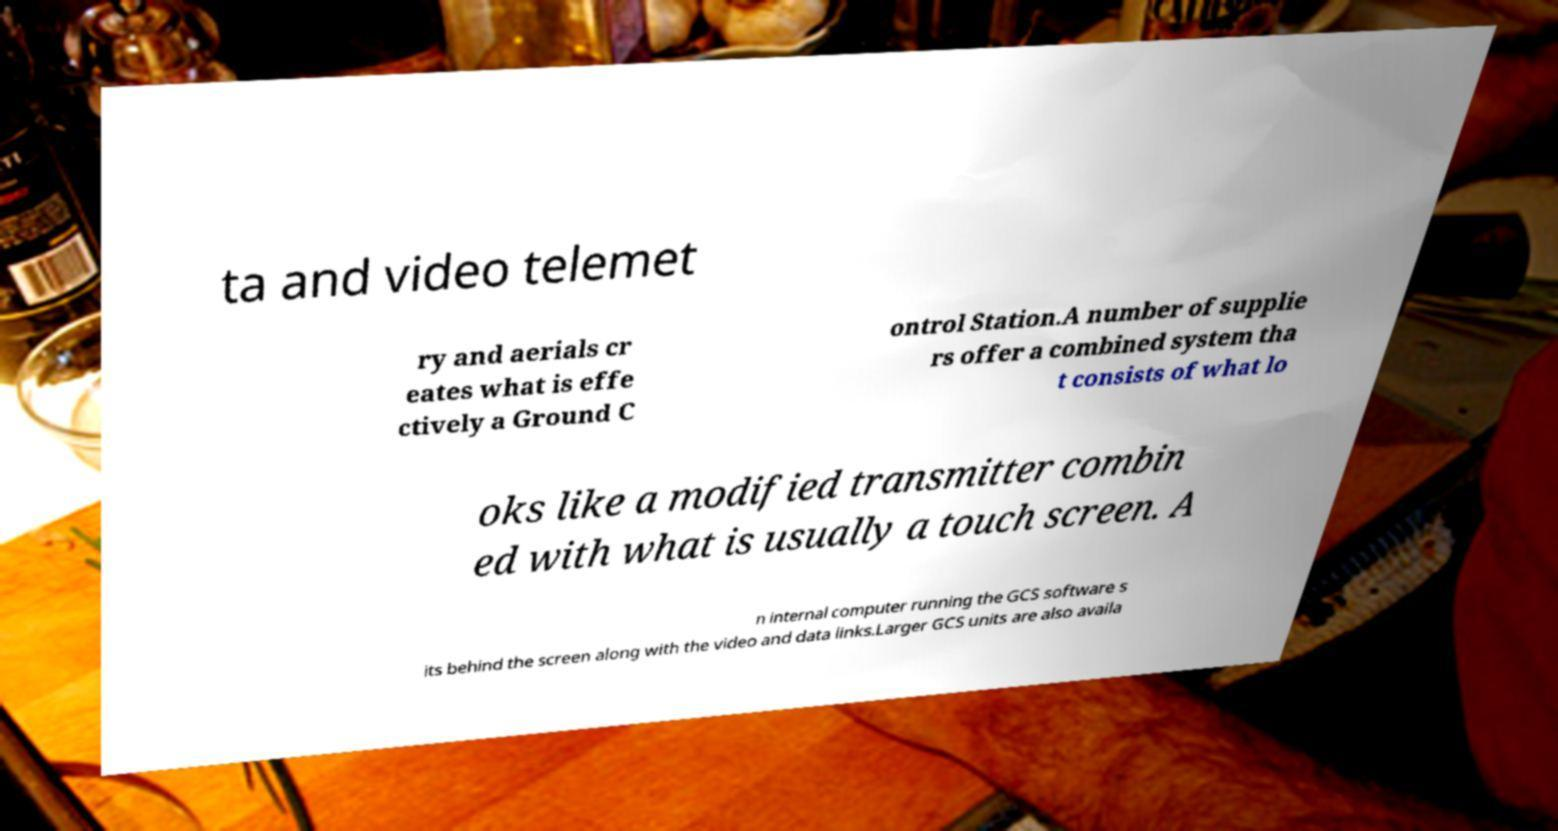Could you extract and type out the text from this image? ta and video telemet ry and aerials cr eates what is effe ctively a Ground C ontrol Station.A number of supplie rs offer a combined system tha t consists of what lo oks like a modified transmitter combin ed with what is usually a touch screen. A n internal computer running the GCS software s its behind the screen along with the video and data links.Larger GCS units are also availa 